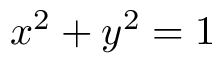Convert formula to latex. <formula><loc_0><loc_0><loc_500><loc_500>x ^ { 2 } + y ^ { 2 } = 1</formula> 